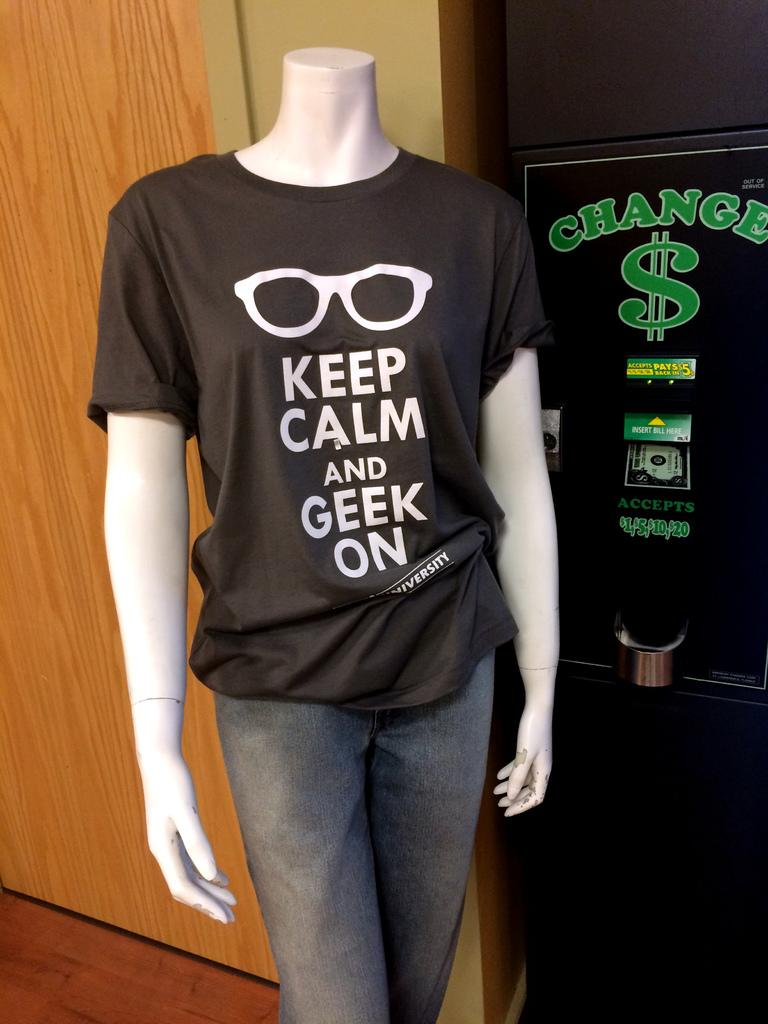<image>
Describe the image concisely. A mannaquin wearing a tshirt that reads Keep Calm and Geek on . 